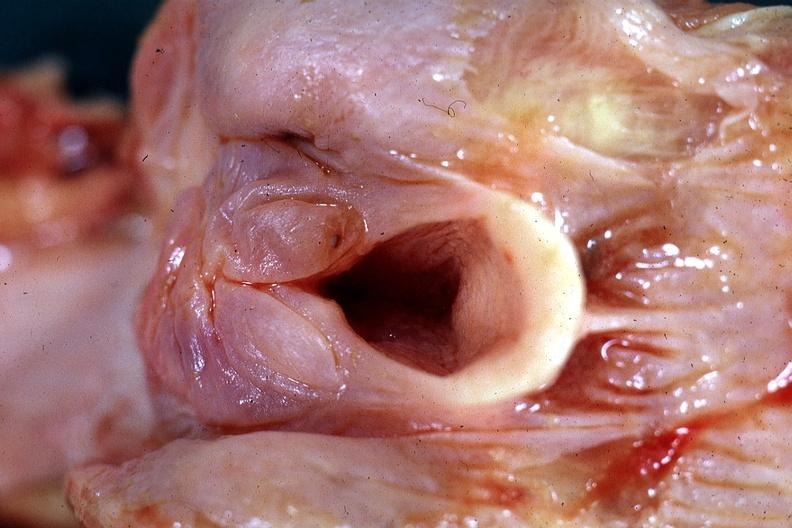what is present?
Answer the question using a single word or phrase. Edema hypopharynx 